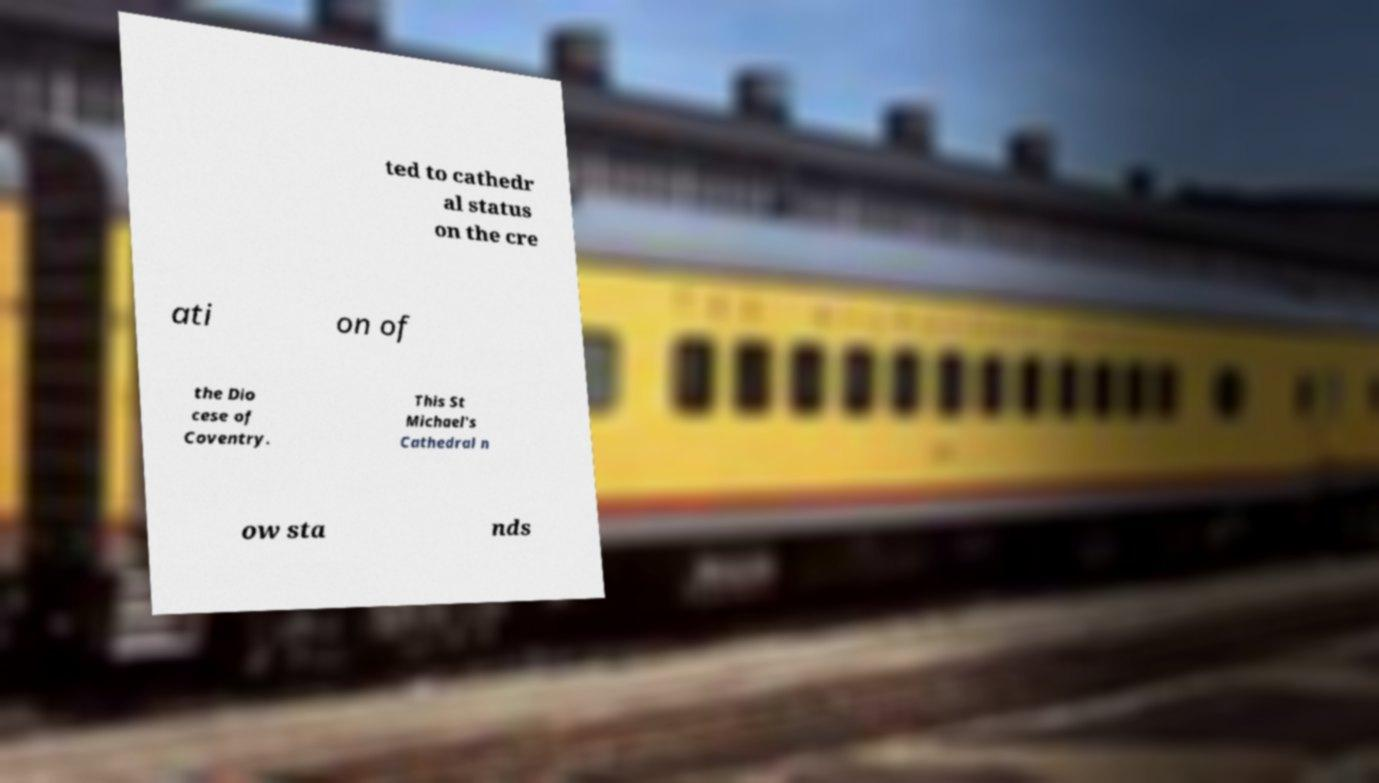What messages or text are displayed in this image? I need them in a readable, typed format. ted to cathedr al status on the cre ati on of the Dio cese of Coventry. This St Michael's Cathedral n ow sta nds 